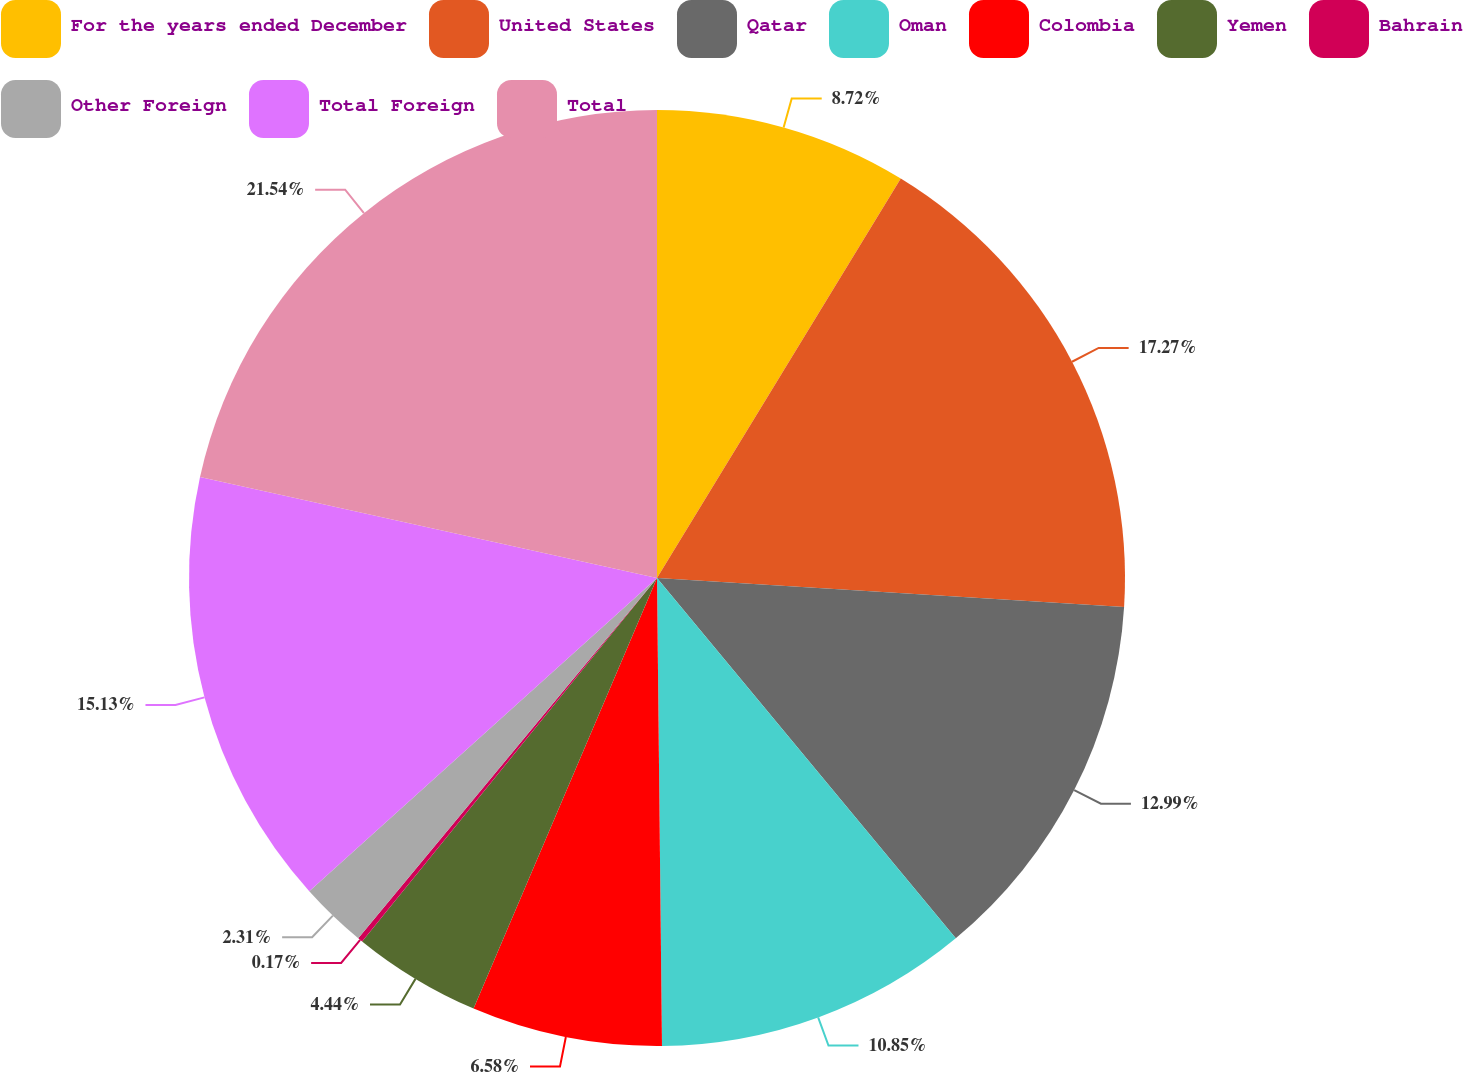<chart> <loc_0><loc_0><loc_500><loc_500><pie_chart><fcel>For the years ended December<fcel>United States<fcel>Qatar<fcel>Oman<fcel>Colombia<fcel>Yemen<fcel>Bahrain<fcel>Other Foreign<fcel>Total Foreign<fcel>Total<nl><fcel>8.72%<fcel>17.27%<fcel>12.99%<fcel>10.85%<fcel>6.58%<fcel>4.44%<fcel>0.17%<fcel>2.31%<fcel>15.13%<fcel>21.54%<nl></chart> 